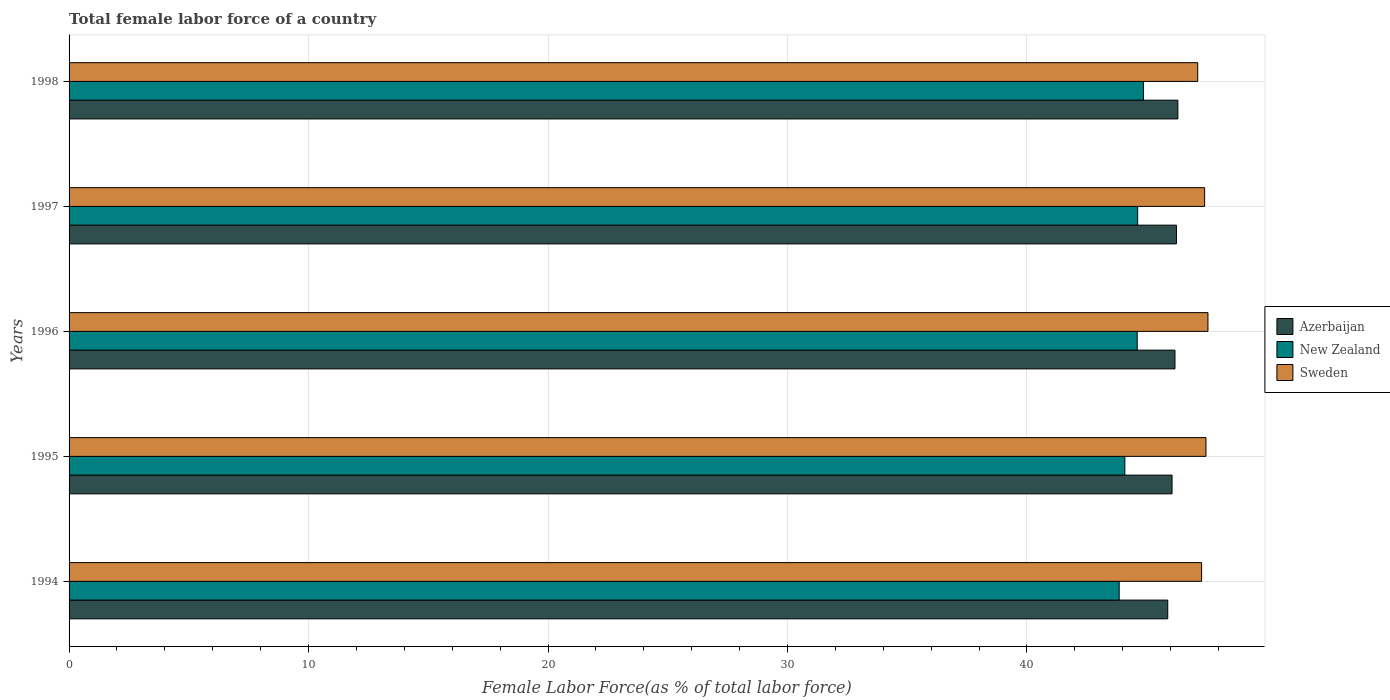How many different coloured bars are there?
Give a very brief answer. 3. Are the number of bars on each tick of the Y-axis equal?
Ensure brevity in your answer.  Yes. How many bars are there on the 3rd tick from the top?
Give a very brief answer. 3. What is the label of the 3rd group of bars from the top?
Provide a short and direct response. 1996. What is the percentage of female labor force in Azerbaijan in 1995?
Keep it short and to the point. 46.06. Across all years, what is the maximum percentage of female labor force in New Zealand?
Your answer should be compact. 44.86. Across all years, what is the minimum percentage of female labor force in Sweden?
Provide a short and direct response. 47.13. In which year was the percentage of female labor force in Azerbaijan maximum?
Keep it short and to the point. 1998. In which year was the percentage of female labor force in Azerbaijan minimum?
Offer a terse response. 1994. What is the total percentage of female labor force in New Zealand in the graph?
Your answer should be very brief. 222.02. What is the difference between the percentage of female labor force in Sweden in 1995 and that in 1998?
Provide a succinct answer. 0.34. What is the difference between the percentage of female labor force in Azerbaijan in 1994 and the percentage of female labor force in New Zealand in 1995?
Ensure brevity in your answer.  1.79. What is the average percentage of female labor force in Azerbaijan per year?
Make the answer very short. 46.13. In the year 1997, what is the difference between the percentage of female labor force in New Zealand and percentage of female labor force in Azerbaijan?
Your answer should be very brief. -1.62. What is the ratio of the percentage of female labor force in Sweden in 1995 to that in 1998?
Provide a short and direct response. 1.01. Is the difference between the percentage of female labor force in New Zealand in 1995 and 1998 greater than the difference between the percentage of female labor force in Azerbaijan in 1995 and 1998?
Ensure brevity in your answer.  No. What is the difference between the highest and the second highest percentage of female labor force in Sweden?
Offer a terse response. 0.08. What is the difference between the highest and the lowest percentage of female labor force in New Zealand?
Ensure brevity in your answer.  1.01. Is the sum of the percentage of female labor force in New Zealand in 1995 and 1997 greater than the maximum percentage of female labor force in Sweden across all years?
Offer a very short reply. Yes. What does the 3rd bar from the top in 1994 represents?
Your answer should be very brief. Azerbaijan. Are all the bars in the graph horizontal?
Make the answer very short. Yes. How many years are there in the graph?
Give a very brief answer. 5. What is the difference between two consecutive major ticks on the X-axis?
Provide a short and direct response. 10. How many legend labels are there?
Offer a terse response. 3. What is the title of the graph?
Offer a very short reply. Total female labor force of a country. Does "Ethiopia" appear as one of the legend labels in the graph?
Make the answer very short. No. What is the label or title of the X-axis?
Give a very brief answer. Female Labor Force(as % of total labor force). What is the Female Labor Force(as % of total labor force) of Azerbaijan in 1994?
Keep it short and to the point. 45.88. What is the Female Labor Force(as % of total labor force) in New Zealand in 1994?
Your answer should be very brief. 43.85. What is the Female Labor Force(as % of total labor force) of Sweden in 1994?
Provide a short and direct response. 47.29. What is the Female Labor Force(as % of total labor force) of Azerbaijan in 1995?
Give a very brief answer. 46.06. What is the Female Labor Force(as % of total labor force) in New Zealand in 1995?
Provide a short and direct response. 44.09. What is the Female Labor Force(as % of total labor force) in Sweden in 1995?
Your response must be concise. 47.47. What is the Female Labor Force(as % of total labor force) of Azerbaijan in 1996?
Your response must be concise. 46.18. What is the Female Labor Force(as % of total labor force) of New Zealand in 1996?
Make the answer very short. 44.6. What is the Female Labor Force(as % of total labor force) in Sweden in 1996?
Offer a very short reply. 47.56. What is the Female Labor Force(as % of total labor force) in Azerbaijan in 1997?
Ensure brevity in your answer.  46.24. What is the Female Labor Force(as % of total labor force) of New Zealand in 1997?
Your answer should be very brief. 44.62. What is the Female Labor Force(as % of total labor force) of Sweden in 1997?
Give a very brief answer. 47.42. What is the Female Labor Force(as % of total labor force) in Azerbaijan in 1998?
Ensure brevity in your answer.  46.3. What is the Female Labor Force(as % of total labor force) in New Zealand in 1998?
Provide a succinct answer. 44.86. What is the Female Labor Force(as % of total labor force) of Sweden in 1998?
Your response must be concise. 47.13. Across all years, what is the maximum Female Labor Force(as % of total labor force) in Azerbaijan?
Offer a terse response. 46.3. Across all years, what is the maximum Female Labor Force(as % of total labor force) in New Zealand?
Your answer should be compact. 44.86. Across all years, what is the maximum Female Labor Force(as % of total labor force) of Sweden?
Provide a short and direct response. 47.56. Across all years, what is the minimum Female Labor Force(as % of total labor force) of Azerbaijan?
Ensure brevity in your answer.  45.88. Across all years, what is the minimum Female Labor Force(as % of total labor force) in New Zealand?
Offer a very short reply. 43.85. Across all years, what is the minimum Female Labor Force(as % of total labor force) in Sweden?
Offer a terse response. 47.13. What is the total Female Labor Force(as % of total labor force) in Azerbaijan in the graph?
Ensure brevity in your answer.  230.66. What is the total Female Labor Force(as % of total labor force) of New Zealand in the graph?
Your answer should be very brief. 222.02. What is the total Female Labor Force(as % of total labor force) of Sweden in the graph?
Make the answer very short. 236.87. What is the difference between the Female Labor Force(as % of total labor force) in Azerbaijan in 1994 and that in 1995?
Your response must be concise. -0.18. What is the difference between the Female Labor Force(as % of total labor force) in New Zealand in 1994 and that in 1995?
Offer a very short reply. -0.24. What is the difference between the Female Labor Force(as % of total labor force) in Sweden in 1994 and that in 1995?
Make the answer very short. -0.18. What is the difference between the Female Labor Force(as % of total labor force) in Azerbaijan in 1994 and that in 1996?
Provide a succinct answer. -0.3. What is the difference between the Female Labor Force(as % of total labor force) of New Zealand in 1994 and that in 1996?
Provide a succinct answer. -0.75. What is the difference between the Female Labor Force(as % of total labor force) of Sweden in 1994 and that in 1996?
Make the answer very short. -0.26. What is the difference between the Female Labor Force(as % of total labor force) in Azerbaijan in 1994 and that in 1997?
Provide a succinct answer. -0.36. What is the difference between the Female Labor Force(as % of total labor force) of New Zealand in 1994 and that in 1997?
Offer a very short reply. -0.77. What is the difference between the Female Labor Force(as % of total labor force) in Sweden in 1994 and that in 1997?
Your answer should be compact. -0.13. What is the difference between the Female Labor Force(as % of total labor force) of Azerbaijan in 1994 and that in 1998?
Ensure brevity in your answer.  -0.42. What is the difference between the Female Labor Force(as % of total labor force) of New Zealand in 1994 and that in 1998?
Your answer should be compact. -1.01. What is the difference between the Female Labor Force(as % of total labor force) of Sweden in 1994 and that in 1998?
Give a very brief answer. 0.16. What is the difference between the Female Labor Force(as % of total labor force) in Azerbaijan in 1995 and that in 1996?
Your response must be concise. -0.12. What is the difference between the Female Labor Force(as % of total labor force) of New Zealand in 1995 and that in 1996?
Offer a very short reply. -0.52. What is the difference between the Female Labor Force(as % of total labor force) of Sweden in 1995 and that in 1996?
Your response must be concise. -0.08. What is the difference between the Female Labor Force(as % of total labor force) of Azerbaijan in 1995 and that in 1997?
Your answer should be compact. -0.18. What is the difference between the Female Labor Force(as % of total labor force) of New Zealand in 1995 and that in 1997?
Your response must be concise. -0.53. What is the difference between the Female Labor Force(as % of total labor force) in Sweden in 1995 and that in 1997?
Offer a very short reply. 0.06. What is the difference between the Female Labor Force(as % of total labor force) of Azerbaijan in 1995 and that in 1998?
Keep it short and to the point. -0.24. What is the difference between the Female Labor Force(as % of total labor force) of New Zealand in 1995 and that in 1998?
Provide a short and direct response. -0.78. What is the difference between the Female Labor Force(as % of total labor force) of Sweden in 1995 and that in 1998?
Offer a very short reply. 0.34. What is the difference between the Female Labor Force(as % of total labor force) in Azerbaijan in 1996 and that in 1997?
Keep it short and to the point. -0.06. What is the difference between the Female Labor Force(as % of total labor force) of New Zealand in 1996 and that in 1997?
Your response must be concise. -0.02. What is the difference between the Female Labor Force(as % of total labor force) in Sweden in 1996 and that in 1997?
Provide a succinct answer. 0.14. What is the difference between the Female Labor Force(as % of total labor force) of Azerbaijan in 1996 and that in 1998?
Keep it short and to the point. -0.12. What is the difference between the Female Labor Force(as % of total labor force) of New Zealand in 1996 and that in 1998?
Offer a terse response. -0.26. What is the difference between the Female Labor Force(as % of total labor force) of Sweden in 1996 and that in 1998?
Your answer should be compact. 0.43. What is the difference between the Female Labor Force(as % of total labor force) in Azerbaijan in 1997 and that in 1998?
Offer a terse response. -0.06. What is the difference between the Female Labor Force(as % of total labor force) of New Zealand in 1997 and that in 1998?
Your answer should be very brief. -0.24. What is the difference between the Female Labor Force(as % of total labor force) in Sweden in 1997 and that in 1998?
Offer a terse response. 0.29. What is the difference between the Female Labor Force(as % of total labor force) in Azerbaijan in 1994 and the Female Labor Force(as % of total labor force) in New Zealand in 1995?
Provide a succinct answer. 1.79. What is the difference between the Female Labor Force(as % of total labor force) in Azerbaijan in 1994 and the Female Labor Force(as % of total labor force) in Sweden in 1995?
Keep it short and to the point. -1.6. What is the difference between the Female Labor Force(as % of total labor force) of New Zealand in 1994 and the Female Labor Force(as % of total labor force) of Sweden in 1995?
Offer a terse response. -3.62. What is the difference between the Female Labor Force(as % of total labor force) in Azerbaijan in 1994 and the Female Labor Force(as % of total labor force) in New Zealand in 1996?
Offer a terse response. 1.28. What is the difference between the Female Labor Force(as % of total labor force) of Azerbaijan in 1994 and the Female Labor Force(as % of total labor force) of Sweden in 1996?
Provide a succinct answer. -1.68. What is the difference between the Female Labor Force(as % of total labor force) of New Zealand in 1994 and the Female Labor Force(as % of total labor force) of Sweden in 1996?
Offer a terse response. -3.71. What is the difference between the Female Labor Force(as % of total labor force) of Azerbaijan in 1994 and the Female Labor Force(as % of total labor force) of New Zealand in 1997?
Provide a short and direct response. 1.26. What is the difference between the Female Labor Force(as % of total labor force) in Azerbaijan in 1994 and the Female Labor Force(as % of total labor force) in Sweden in 1997?
Give a very brief answer. -1.54. What is the difference between the Female Labor Force(as % of total labor force) of New Zealand in 1994 and the Female Labor Force(as % of total labor force) of Sweden in 1997?
Ensure brevity in your answer.  -3.57. What is the difference between the Female Labor Force(as % of total labor force) in Azerbaijan in 1994 and the Female Labor Force(as % of total labor force) in New Zealand in 1998?
Your answer should be very brief. 1.01. What is the difference between the Female Labor Force(as % of total labor force) in Azerbaijan in 1994 and the Female Labor Force(as % of total labor force) in Sweden in 1998?
Offer a terse response. -1.25. What is the difference between the Female Labor Force(as % of total labor force) of New Zealand in 1994 and the Female Labor Force(as % of total labor force) of Sweden in 1998?
Make the answer very short. -3.28. What is the difference between the Female Labor Force(as % of total labor force) of Azerbaijan in 1995 and the Female Labor Force(as % of total labor force) of New Zealand in 1996?
Keep it short and to the point. 1.46. What is the difference between the Female Labor Force(as % of total labor force) in Azerbaijan in 1995 and the Female Labor Force(as % of total labor force) in Sweden in 1996?
Your response must be concise. -1.5. What is the difference between the Female Labor Force(as % of total labor force) of New Zealand in 1995 and the Female Labor Force(as % of total labor force) of Sweden in 1996?
Provide a succinct answer. -3.47. What is the difference between the Female Labor Force(as % of total labor force) in Azerbaijan in 1995 and the Female Labor Force(as % of total labor force) in New Zealand in 1997?
Offer a terse response. 1.44. What is the difference between the Female Labor Force(as % of total labor force) in Azerbaijan in 1995 and the Female Labor Force(as % of total labor force) in Sweden in 1997?
Your response must be concise. -1.36. What is the difference between the Female Labor Force(as % of total labor force) of New Zealand in 1995 and the Female Labor Force(as % of total labor force) of Sweden in 1997?
Your response must be concise. -3.33. What is the difference between the Female Labor Force(as % of total labor force) of Azerbaijan in 1995 and the Female Labor Force(as % of total labor force) of New Zealand in 1998?
Offer a terse response. 1.19. What is the difference between the Female Labor Force(as % of total labor force) of Azerbaijan in 1995 and the Female Labor Force(as % of total labor force) of Sweden in 1998?
Keep it short and to the point. -1.07. What is the difference between the Female Labor Force(as % of total labor force) of New Zealand in 1995 and the Female Labor Force(as % of total labor force) of Sweden in 1998?
Give a very brief answer. -3.04. What is the difference between the Female Labor Force(as % of total labor force) in Azerbaijan in 1996 and the Female Labor Force(as % of total labor force) in New Zealand in 1997?
Provide a succinct answer. 1.56. What is the difference between the Female Labor Force(as % of total labor force) of Azerbaijan in 1996 and the Female Labor Force(as % of total labor force) of Sweden in 1997?
Offer a very short reply. -1.24. What is the difference between the Female Labor Force(as % of total labor force) of New Zealand in 1996 and the Female Labor Force(as % of total labor force) of Sweden in 1997?
Provide a succinct answer. -2.82. What is the difference between the Female Labor Force(as % of total labor force) in Azerbaijan in 1996 and the Female Labor Force(as % of total labor force) in New Zealand in 1998?
Your answer should be compact. 1.32. What is the difference between the Female Labor Force(as % of total labor force) of Azerbaijan in 1996 and the Female Labor Force(as % of total labor force) of Sweden in 1998?
Give a very brief answer. -0.95. What is the difference between the Female Labor Force(as % of total labor force) in New Zealand in 1996 and the Female Labor Force(as % of total labor force) in Sweden in 1998?
Provide a short and direct response. -2.53. What is the difference between the Female Labor Force(as % of total labor force) of Azerbaijan in 1997 and the Female Labor Force(as % of total labor force) of New Zealand in 1998?
Provide a short and direct response. 1.38. What is the difference between the Female Labor Force(as % of total labor force) of Azerbaijan in 1997 and the Female Labor Force(as % of total labor force) of Sweden in 1998?
Keep it short and to the point. -0.89. What is the difference between the Female Labor Force(as % of total labor force) in New Zealand in 1997 and the Female Labor Force(as % of total labor force) in Sweden in 1998?
Provide a succinct answer. -2.51. What is the average Female Labor Force(as % of total labor force) of Azerbaijan per year?
Offer a terse response. 46.13. What is the average Female Labor Force(as % of total labor force) in New Zealand per year?
Give a very brief answer. 44.4. What is the average Female Labor Force(as % of total labor force) of Sweden per year?
Your response must be concise. 47.37. In the year 1994, what is the difference between the Female Labor Force(as % of total labor force) of Azerbaijan and Female Labor Force(as % of total labor force) of New Zealand?
Offer a very short reply. 2.03. In the year 1994, what is the difference between the Female Labor Force(as % of total labor force) of Azerbaijan and Female Labor Force(as % of total labor force) of Sweden?
Make the answer very short. -1.41. In the year 1994, what is the difference between the Female Labor Force(as % of total labor force) of New Zealand and Female Labor Force(as % of total labor force) of Sweden?
Make the answer very short. -3.44. In the year 1995, what is the difference between the Female Labor Force(as % of total labor force) in Azerbaijan and Female Labor Force(as % of total labor force) in New Zealand?
Provide a short and direct response. 1.97. In the year 1995, what is the difference between the Female Labor Force(as % of total labor force) in Azerbaijan and Female Labor Force(as % of total labor force) in Sweden?
Offer a very short reply. -1.42. In the year 1995, what is the difference between the Female Labor Force(as % of total labor force) in New Zealand and Female Labor Force(as % of total labor force) in Sweden?
Offer a terse response. -3.39. In the year 1996, what is the difference between the Female Labor Force(as % of total labor force) of Azerbaijan and Female Labor Force(as % of total labor force) of New Zealand?
Your answer should be very brief. 1.58. In the year 1996, what is the difference between the Female Labor Force(as % of total labor force) of Azerbaijan and Female Labor Force(as % of total labor force) of Sweden?
Keep it short and to the point. -1.38. In the year 1996, what is the difference between the Female Labor Force(as % of total labor force) in New Zealand and Female Labor Force(as % of total labor force) in Sweden?
Offer a very short reply. -2.95. In the year 1997, what is the difference between the Female Labor Force(as % of total labor force) of Azerbaijan and Female Labor Force(as % of total labor force) of New Zealand?
Offer a very short reply. 1.62. In the year 1997, what is the difference between the Female Labor Force(as % of total labor force) of Azerbaijan and Female Labor Force(as % of total labor force) of Sweden?
Your response must be concise. -1.18. In the year 1997, what is the difference between the Female Labor Force(as % of total labor force) of New Zealand and Female Labor Force(as % of total labor force) of Sweden?
Offer a terse response. -2.8. In the year 1998, what is the difference between the Female Labor Force(as % of total labor force) in Azerbaijan and Female Labor Force(as % of total labor force) in New Zealand?
Your response must be concise. 1.44. In the year 1998, what is the difference between the Female Labor Force(as % of total labor force) of Azerbaijan and Female Labor Force(as % of total labor force) of Sweden?
Ensure brevity in your answer.  -0.83. In the year 1998, what is the difference between the Female Labor Force(as % of total labor force) of New Zealand and Female Labor Force(as % of total labor force) of Sweden?
Your response must be concise. -2.27. What is the ratio of the Female Labor Force(as % of total labor force) of New Zealand in 1994 to that in 1995?
Ensure brevity in your answer.  0.99. What is the ratio of the Female Labor Force(as % of total labor force) in New Zealand in 1994 to that in 1996?
Keep it short and to the point. 0.98. What is the ratio of the Female Labor Force(as % of total labor force) in Azerbaijan in 1994 to that in 1997?
Offer a very short reply. 0.99. What is the ratio of the Female Labor Force(as % of total labor force) in New Zealand in 1994 to that in 1997?
Make the answer very short. 0.98. What is the ratio of the Female Labor Force(as % of total labor force) of Sweden in 1994 to that in 1997?
Your answer should be compact. 1. What is the ratio of the Female Labor Force(as % of total labor force) in Azerbaijan in 1994 to that in 1998?
Provide a succinct answer. 0.99. What is the ratio of the Female Labor Force(as % of total labor force) of New Zealand in 1994 to that in 1998?
Ensure brevity in your answer.  0.98. What is the ratio of the Female Labor Force(as % of total labor force) in Sweden in 1994 to that in 1998?
Give a very brief answer. 1. What is the ratio of the Female Labor Force(as % of total labor force) in Azerbaijan in 1995 to that in 1996?
Offer a very short reply. 1. What is the ratio of the Female Labor Force(as % of total labor force) in New Zealand in 1995 to that in 1996?
Your answer should be compact. 0.99. What is the ratio of the Female Labor Force(as % of total labor force) of Sweden in 1995 to that in 1997?
Make the answer very short. 1. What is the ratio of the Female Labor Force(as % of total labor force) in Azerbaijan in 1995 to that in 1998?
Offer a very short reply. 0.99. What is the ratio of the Female Labor Force(as % of total labor force) of New Zealand in 1995 to that in 1998?
Provide a succinct answer. 0.98. What is the ratio of the Female Labor Force(as % of total labor force) in Sweden in 1995 to that in 1998?
Provide a short and direct response. 1.01. What is the ratio of the Female Labor Force(as % of total labor force) of Azerbaijan in 1996 to that in 1997?
Your answer should be compact. 1. What is the ratio of the Female Labor Force(as % of total labor force) of New Zealand in 1996 to that in 1997?
Keep it short and to the point. 1. What is the ratio of the Female Labor Force(as % of total labor force) in Sweden in 1996 to that in 1998?
Ensure brevity in your answer.  1.01. What is the ratio of the Female Labor Force(as % of total labor force) in New Zealand in 1997 to that in 1998?
Provide a short and direct response. 0.99. What is the ratio of the Female Labor Force(as % of total labor force) in Sweden in 1997 to that in 1998?
Ensure brevity in your answer.  1.01. What is the difference between the highest and the second highest Female Labor Force(as % of total labor force) in Azerbaijan?
Your response must be concise. 0.06. What is the difference between the highest and the second highest Female Labor Force(as % of total labor force) of New Zealand?
Offer a very short reply. 0.24. What is the difference between the highest and the second highest Female Labor Force(as % of total labor force) of Sweden?
Your answer should be very brief. 0.08. What is the difference between the highest and the lowest Female Labor Force(as % of total labor force) in Azerbaijan?
Give a very brief answer. 0.42. What is the difference between the highest and the lowest Female Labor Force(as % of total labor force) in New Zealand?
Give a very brief answer. 1.01. What is the difference between the highest and the lowest Female Labor Force(as % of total labor force) in Sweden?
Ensure brevity in your answer.  0.43. 